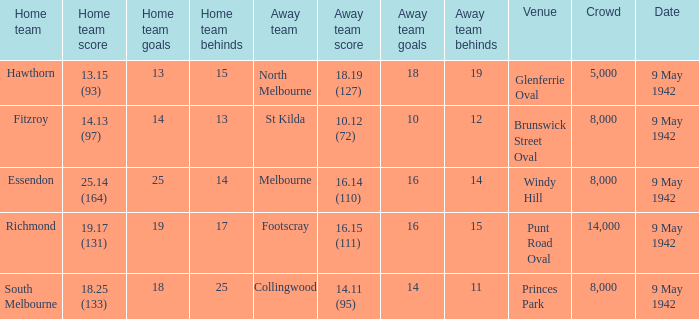How large was the crowd with a home team score of 18.25 (133)? 8000.0. 